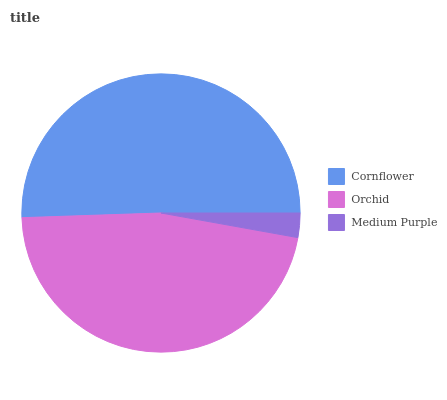Is Medium Purple the minimum?
Answer yes or no. Yes. Is Cornflower the maximum?
Answer yes or no. Yes. Is Orchid the minimum?
Answer yes or no. No. Is Orchid the maximum?
Answer yes or no. No. Is Cornflower greater than Orchid?
Answer yes or no. Yes. Is Orchid less than Cornflower?
Answer yes or no. Yes. Is Orchid greater than Cornflower?
Answer yes or no. No. Is Cornflower less than Orchid?
Answer yes or no. No. Is Orchid the high median?
Answer yes or no. Yes. Is Orchid the low median?
Answer yes or no. Yes. Is Medium Purple the high median?
Answer yes or no. No. Is Medium Purple the low median?
Answer yes or no. No. 